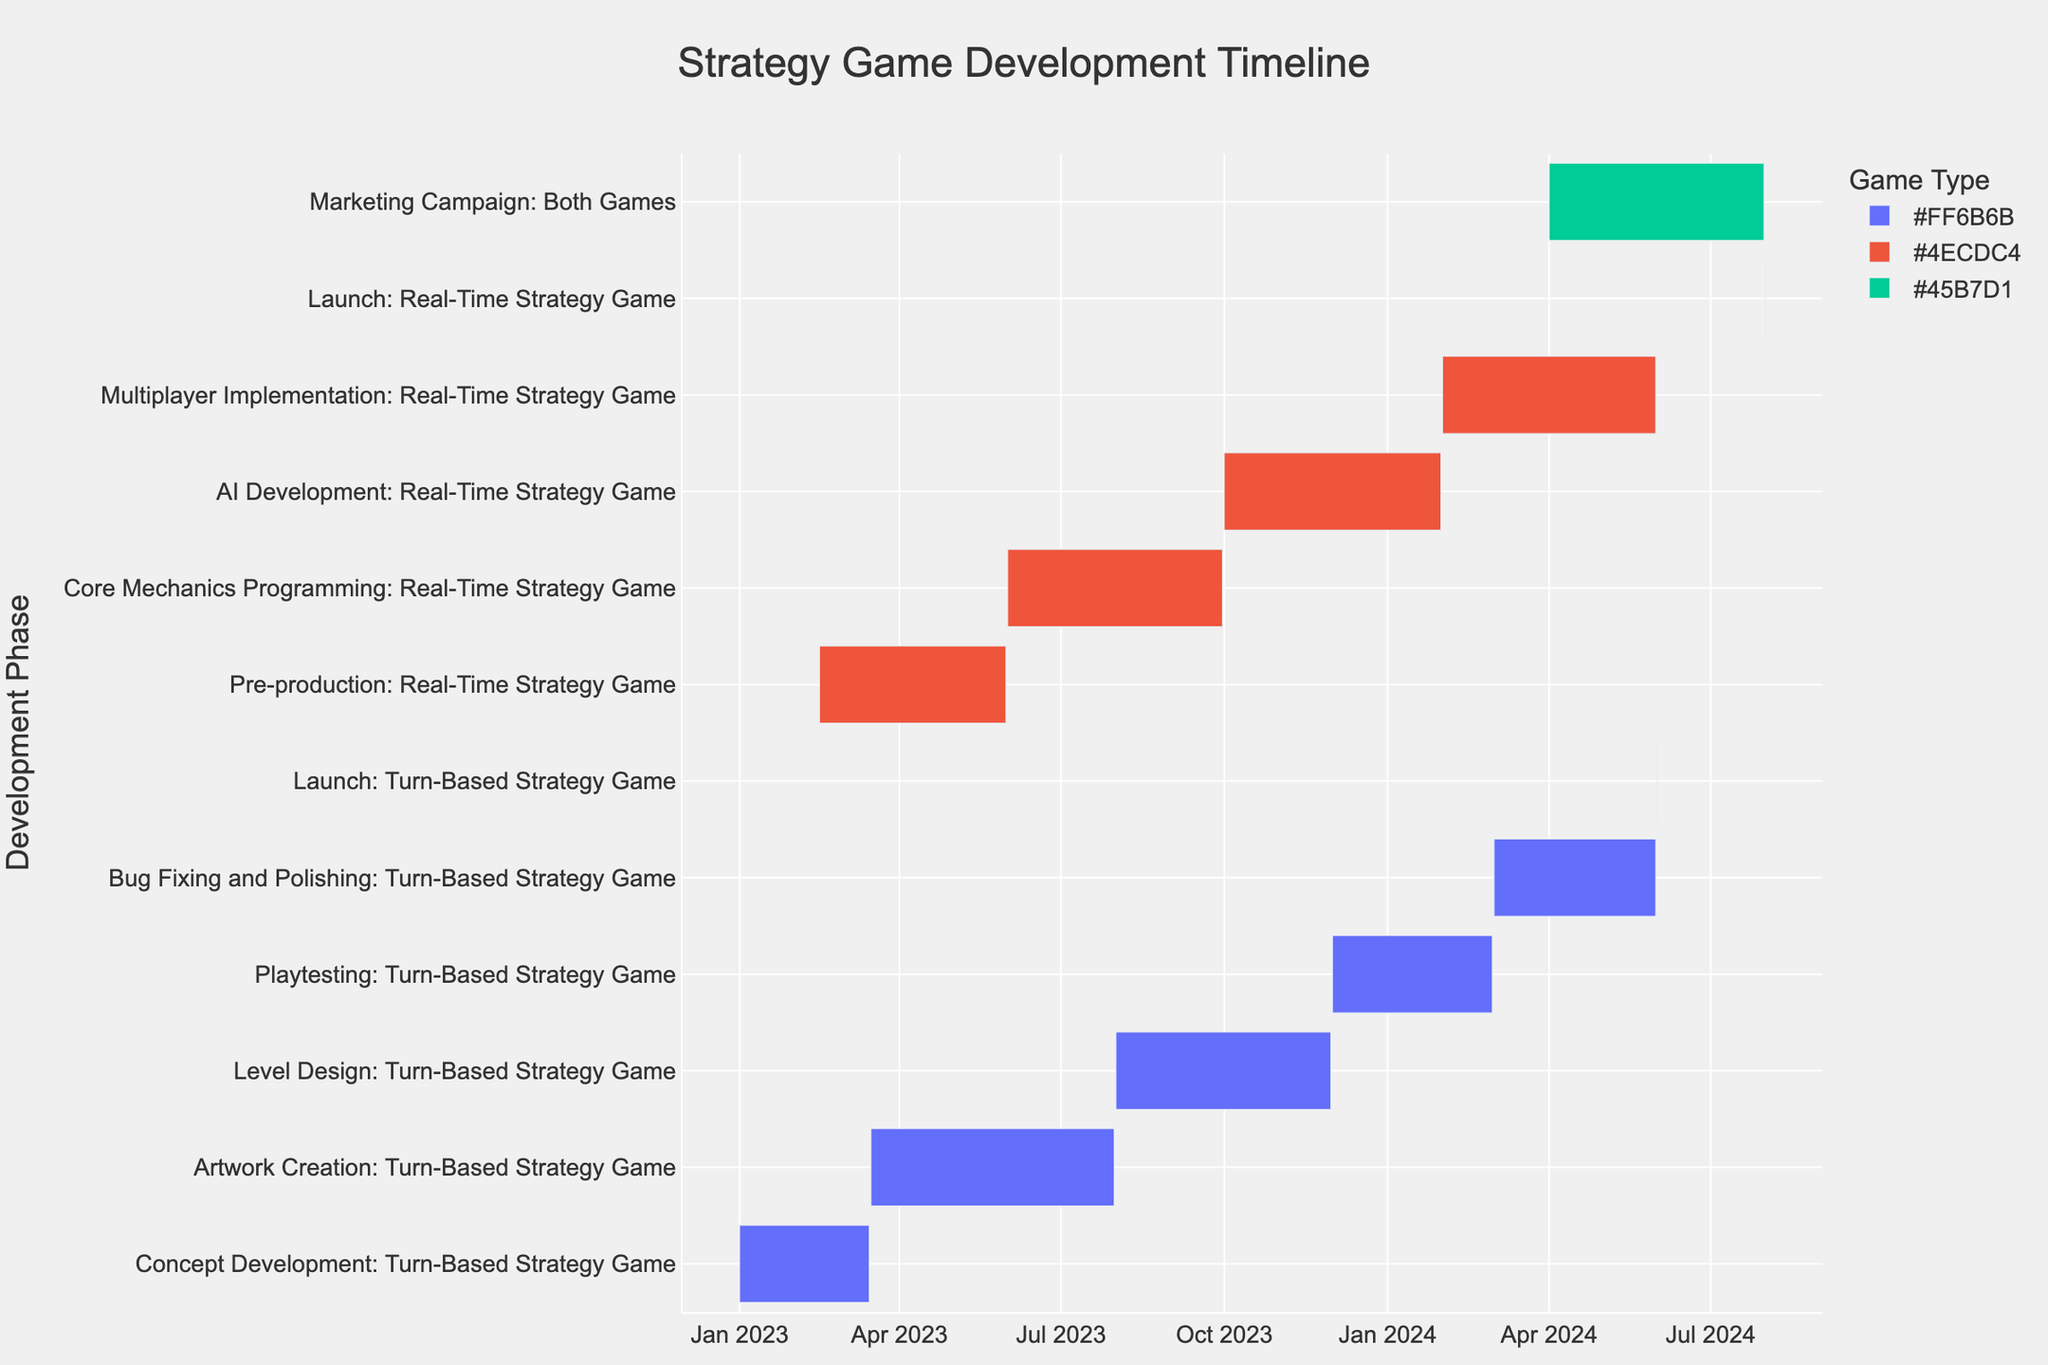Which task has the shortest duration? The Launch phase for both games has the shortest duration of just 1 day. This can be identified by inspecting the bars on the chart and noticing which has the least width (length of time).
Answer: Launch: Turn-Based Strategy Game and Launch: Real-Time Strategy Game How many months does the Level Design phase for the Turn-Based Strategy Game span? Level Design starts on August 1, 2023, and ends on November 30, 2023. Counting the months from August to November gives the total duration.
Answer: 4 months Which phase overlaps with the AI Development phase for the Real-Time Strategy Game? The AI Development phase runs from October 1, 2023, to January 31, 2024. By inspecting the other phases that overlap within this time frame on the chart, we find the Playtesting phase for the Turn-Based Strategy Game (December 2023 - February 2024) and the Multiplayer Implementation phase for the Real-Time Strategy Game (February 2024 - May 2024).
Answer: Playtesting: Turn-Based Strategy Game What is the total duration of all phases for the Turn-Based Strategy Game? Sum the durations of each Turn-Based Strategy Game phase: Concept Development (74 days), Artwork Creation (138 days), Level Design (122 days), Playtesting (91 days), Bug Fixing and Polishing (92 days). The total is 74 + 138 + 122 + 91 + 92 = 517 days.
Answer: 517 days Which game has its main development phases spread out over a longer period? By comparing the start and end dates of the main phases for both games, we see that the Turn-Based Strategy Game ranges from January 1, 2023, to May 31, 2024, whereas the Real-Time Strategy Game ranges from February 15, 2023, to May 31, 2024. The Turn-Based Strategy Game spans 17 months while the Real-Time Strategy Game spans 15.5 months.
Answer: Turn-Based Strategy Game What is the duration of the Marketing Campaign phase? The Marketing Campaign runs from April 1, 2024, to July 31, 2024. To find the duration in days, count the number of days between these dates: April (30 days), May (31 days), June (30 days), and July (31 days), summing up to 122 days.
Answer: 122 days Which phase immediately follows the Core Mechanics Programming for the Real-Time Strategy Game? Immediate succession in a Gantt Chart can be visualized by the bar that starts right after the Core Mechanics Programming phase, which ends on September 30, 2023. AI Development starts on October 1, 2023, which immediately follows.
Answer: AI Development: Real-Time Strategy Game When does the Playtesting phase for the Turn-Based Strategy Game start and end? By inspecting the chart, the Playtesting phase starts on December 1, 2023, and ends on February 29, 2024.
Answer: December 1, 2023 - February 29, 2024 Which task takes the longest time to complete? The task with the longest duration is Artwork Creation for the Turn-Based Strategy Game, which spans from March 16, 2023, to July 31, 2023, totaling 138 days.
Answer: Artwork Creation: Turn-Based Strategy Game 